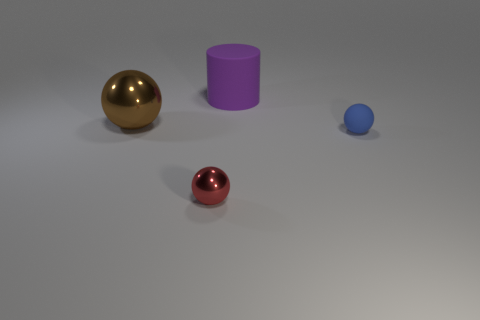There is a ball that is right of the large purple matte cylinder; is there a small blue thing to the right of it?
Your response must be concise. No. Are there any tiny red objects behind the large rubber cylinder?
Ensure brevity in your answer.  No. There is a rubber object right of the big purple rubber cylinder; is it the same shape as the large brown thing?
Offer a terse response. Yes. How many other blue objects have the same shape as the big metal object?
Make the answer very short. 1. Is there a blue sphere made of the same material as the small blue thing?
Make the answer very short. No. What material is the tiny object that is behind the small object that is in front of the tiny blue sphere?
Your answer should be very brief. Rubber. There is a ball behind the small blue object; how big is it?
Offer a very short reply. Large. There is a matte cylinder; is its color the same as the matte object on the right side of the purple matte cylinder?
Offer a very short reply. No. Are there any tiny rubber things of the same color as the big matte thing?
Offer a terse response. No. Is the material of the brown thing the same as the thing on the right side of the purple matte thing?
Give a very brief answer. No. 